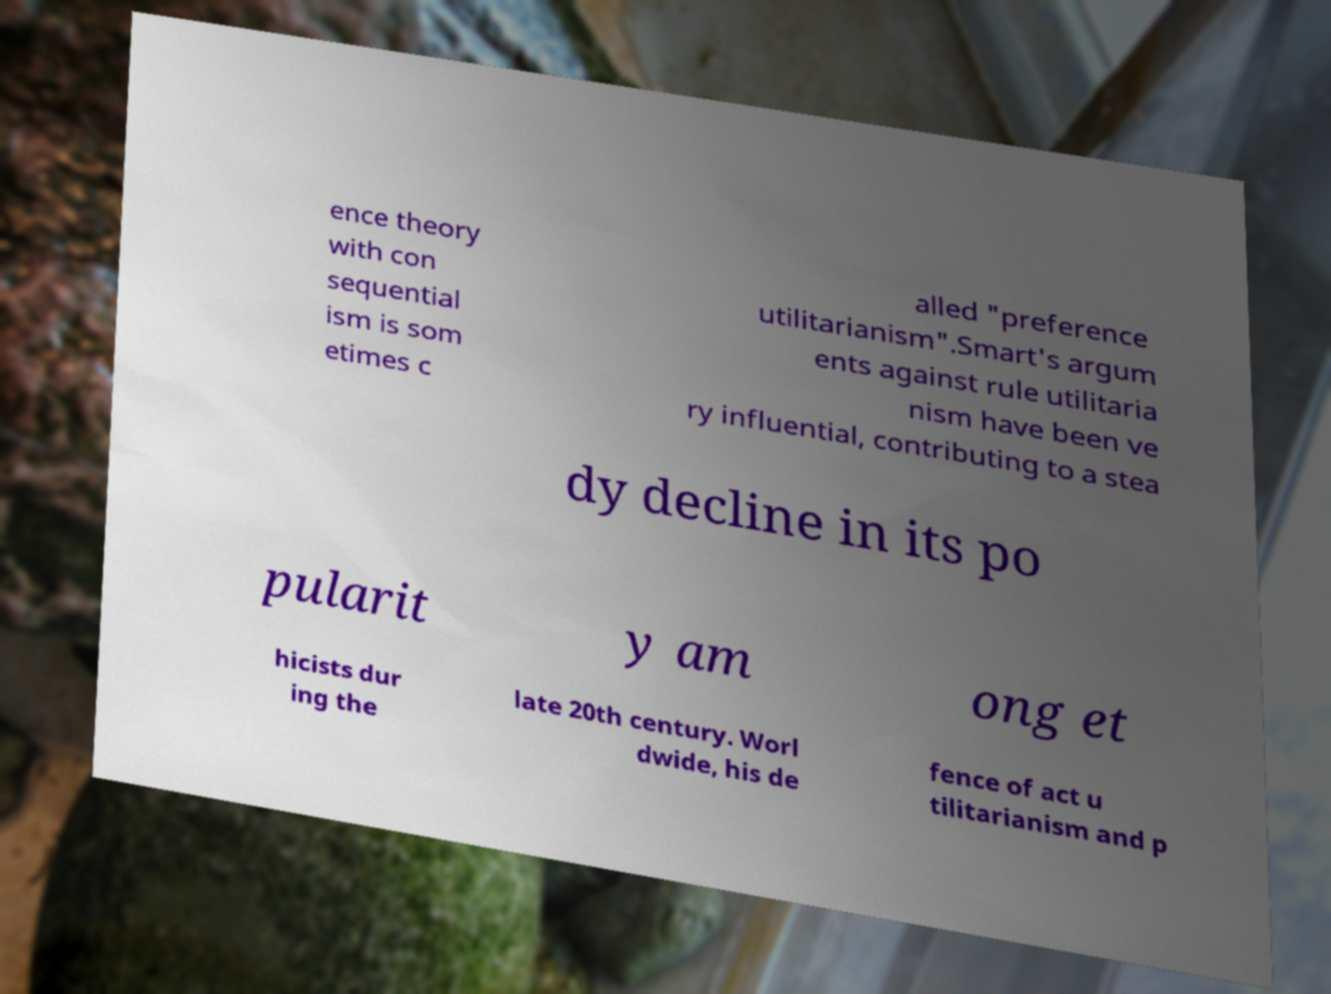Please read and relay the text visible in this image. What does it say? ence theory with con sequential ism is som etimes c alled "preference utilitarianism".Smart's argum ents against rule utilitaria nism have been ve ry influential, contributing to a stea dy decline in its po pularit y am ong et hicists dur ing the late 20th century. Worl dwide, his de fence of act u tilitarianism and p 